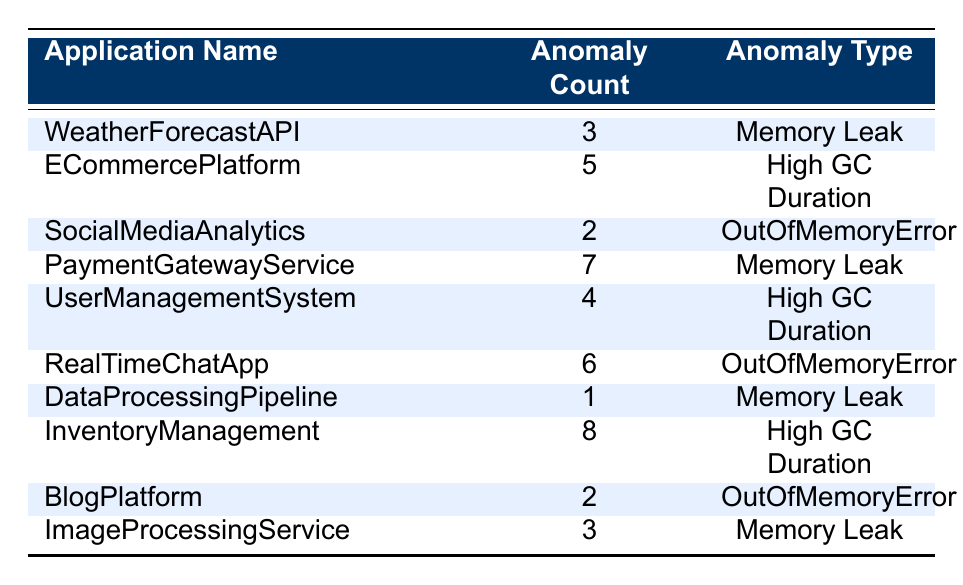What is the application with the highest anomaly count? By reviewing the table, we find that the application "InventoryManagement" has the highest anomaly count of 8.
Answer: InventoryManagement How many applications recorded a "Memory Leak" type anomaly? The table lists three applications with the "Memory Leak" anomaly: "WeatherForecastAPI," "PaymentGatewayService," and "ImageProcessingService."
Answer: 3 What is the total count of anomalies classified as "High GC Duration"? To find the total, we sum the anomaly counts for "ECommercePlatform" (5), "UserManagementSystem" (4), and "InventoryManagement" (8), giving us 5 + 4 + 8 = 17.
Answer: 17 Are there any applications listed that experienced an "OutOfMemoryError"? By examining the table, we see "SocialMediaAnalytics," "RealTimeChatApp," and "BlogPlatform" have the "OutOfMemoryError" anomaly. So, yes, there are applications with this anomaly.
Answer: Yes What is the average anomaly count for all applications dealing with "Memory Leak"? We take the anomaly counts for the relevant applications: "WeatherForecastAPI" (3), "PaymentGatewayService" (7), "DataProcessingPipeline" (1), and "ImageProcessingService" (3). The total is 3 + 7 + 1 + 3 = 14, and there are 4 such applications, so the average is 14/4 = 3.5.
Answer: 3.5 Which anomaly type has the highest total anomaly count across all applications? We sum the counts: "Memory Leak" (3 + 7 + 1 + 3 = 14), "High GC Duration" (5 + 4 + 8 = 17), and "OutOfMemoryError" (2 + 6 + 2 = 10). "High GC Duration" has the highest total count of 17.
Answer: High GC Duration How many applications have an anomaly count less than 3? From the table, the only application with an anomaly count less than 3 is "DataProcessingPipeline," which has a count of 1, and "SocialMediaAnalytics" and "BlogPlatform" which have counts of 2 each. Thus, there are three applications.
Answer: 3 Do any applications show a count of 6 for anomalies? Checking the anomaly counts listed, “RealTimeChatApp” is noted to have an anomaly count of 6. Therefore, the answer to this question is yes.
Answer: Yes 